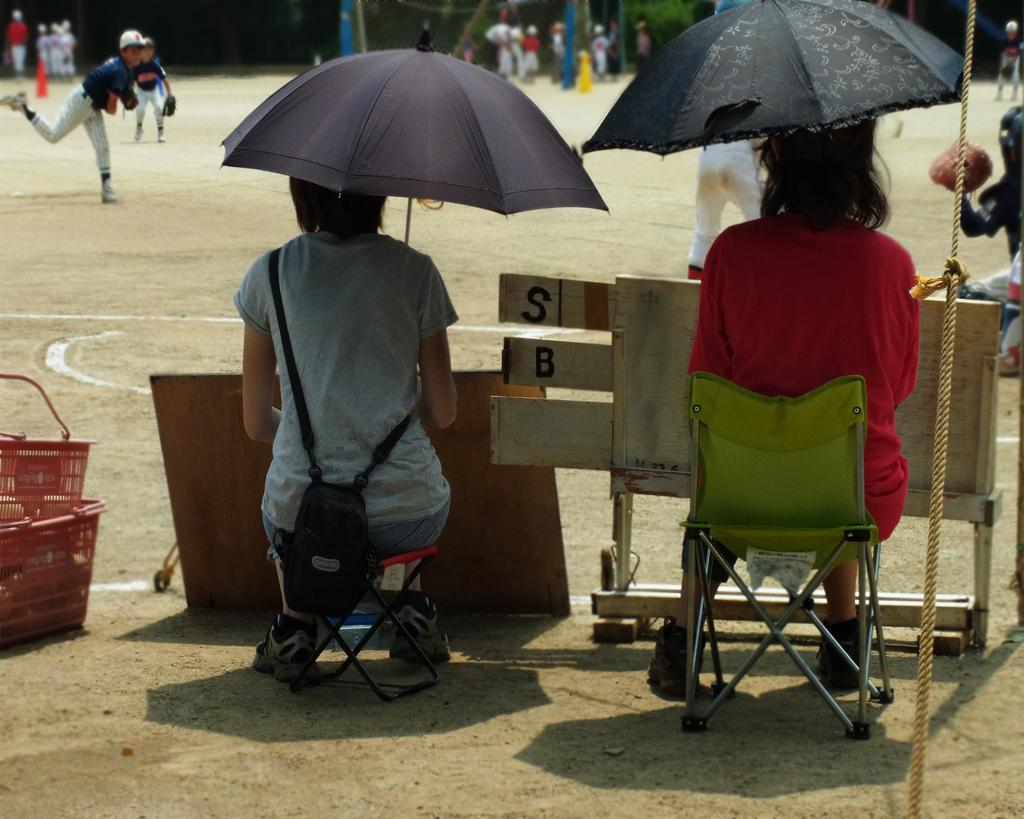How many people are sitting in the image? There are two persons sitting in the image. What are the sitting persons holding? The two persons are holding an umbrella. What is the position of the standing people in relation to the sitting persons? There are people standing in front of the sitting persons. What language is the uncle speaking in the image? There is no uncle present in the image, and therefore no language can be attributed to him. 